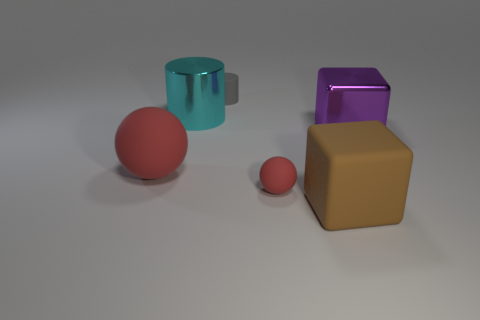Add 2 large red metal things. How many objects exist? 8 Subtract all cyan cylinders. How many cylinders are left? 1 Subtract all cubes. How many objects are left? 4 Add 5 blue rubber blocks. How many blue rubber blocks exist? 5 Subtract 0 purple spheres. How many objects are left? 6 Subtract 2 spheres. How many spheres are left? 0 Subtract all gray cylinders. Subtract all brown cubes. How many cylinders are left? 1 Subtract all brown cubes. How many cyan cylinders are left? 1 Subtract all tiny red things. Subtract all small gray rubber objects. How many objects are left? 4 Add 5 tiny gray cylinders. How many tiny gray cylinders are left? 6 